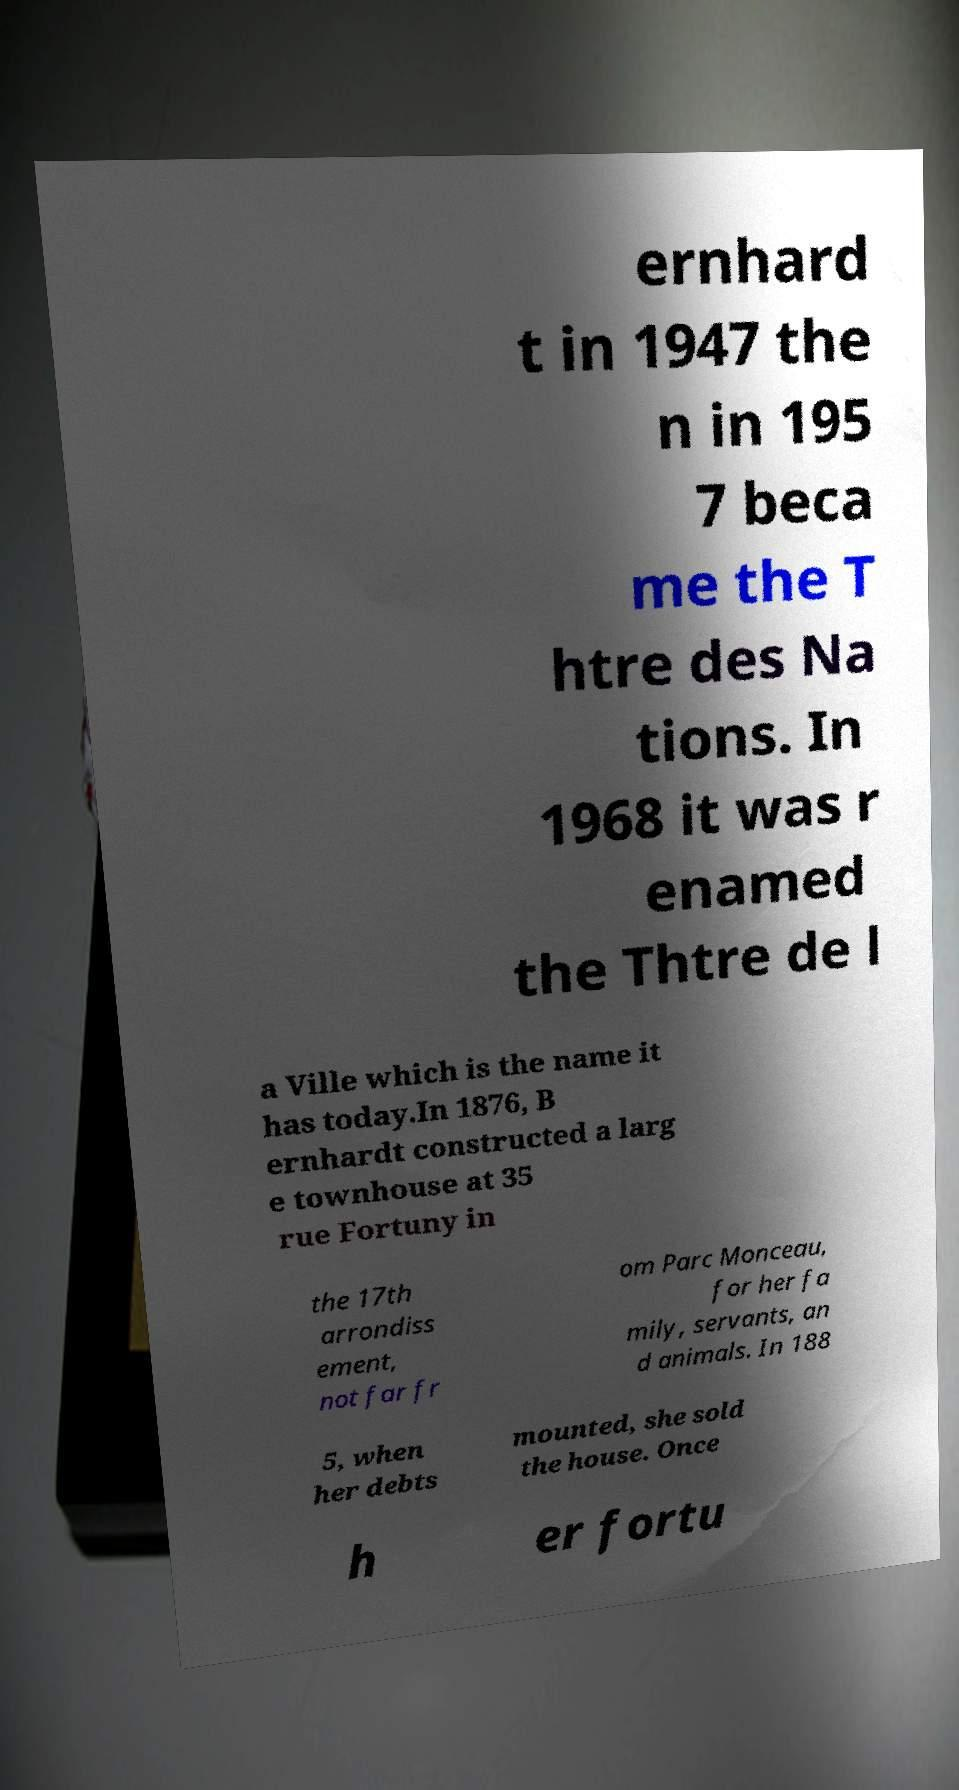Could you extract and type out the text from this image? ernhard t in 1947 the n in 195 7 beca me the T htre des Na tions. In 1968 it was r enamed the Thtre de l a Ville which is the name it has today.In 1876, B ernhardt constructed a larg e townhouse at 35 rue Fortuny in the 17th arrondiss ement, not far fr om Parc Monceau, for her fa mily, servants, an d animals. In 188 5, when her debts mounted, she sold the house. Once h er fortu 